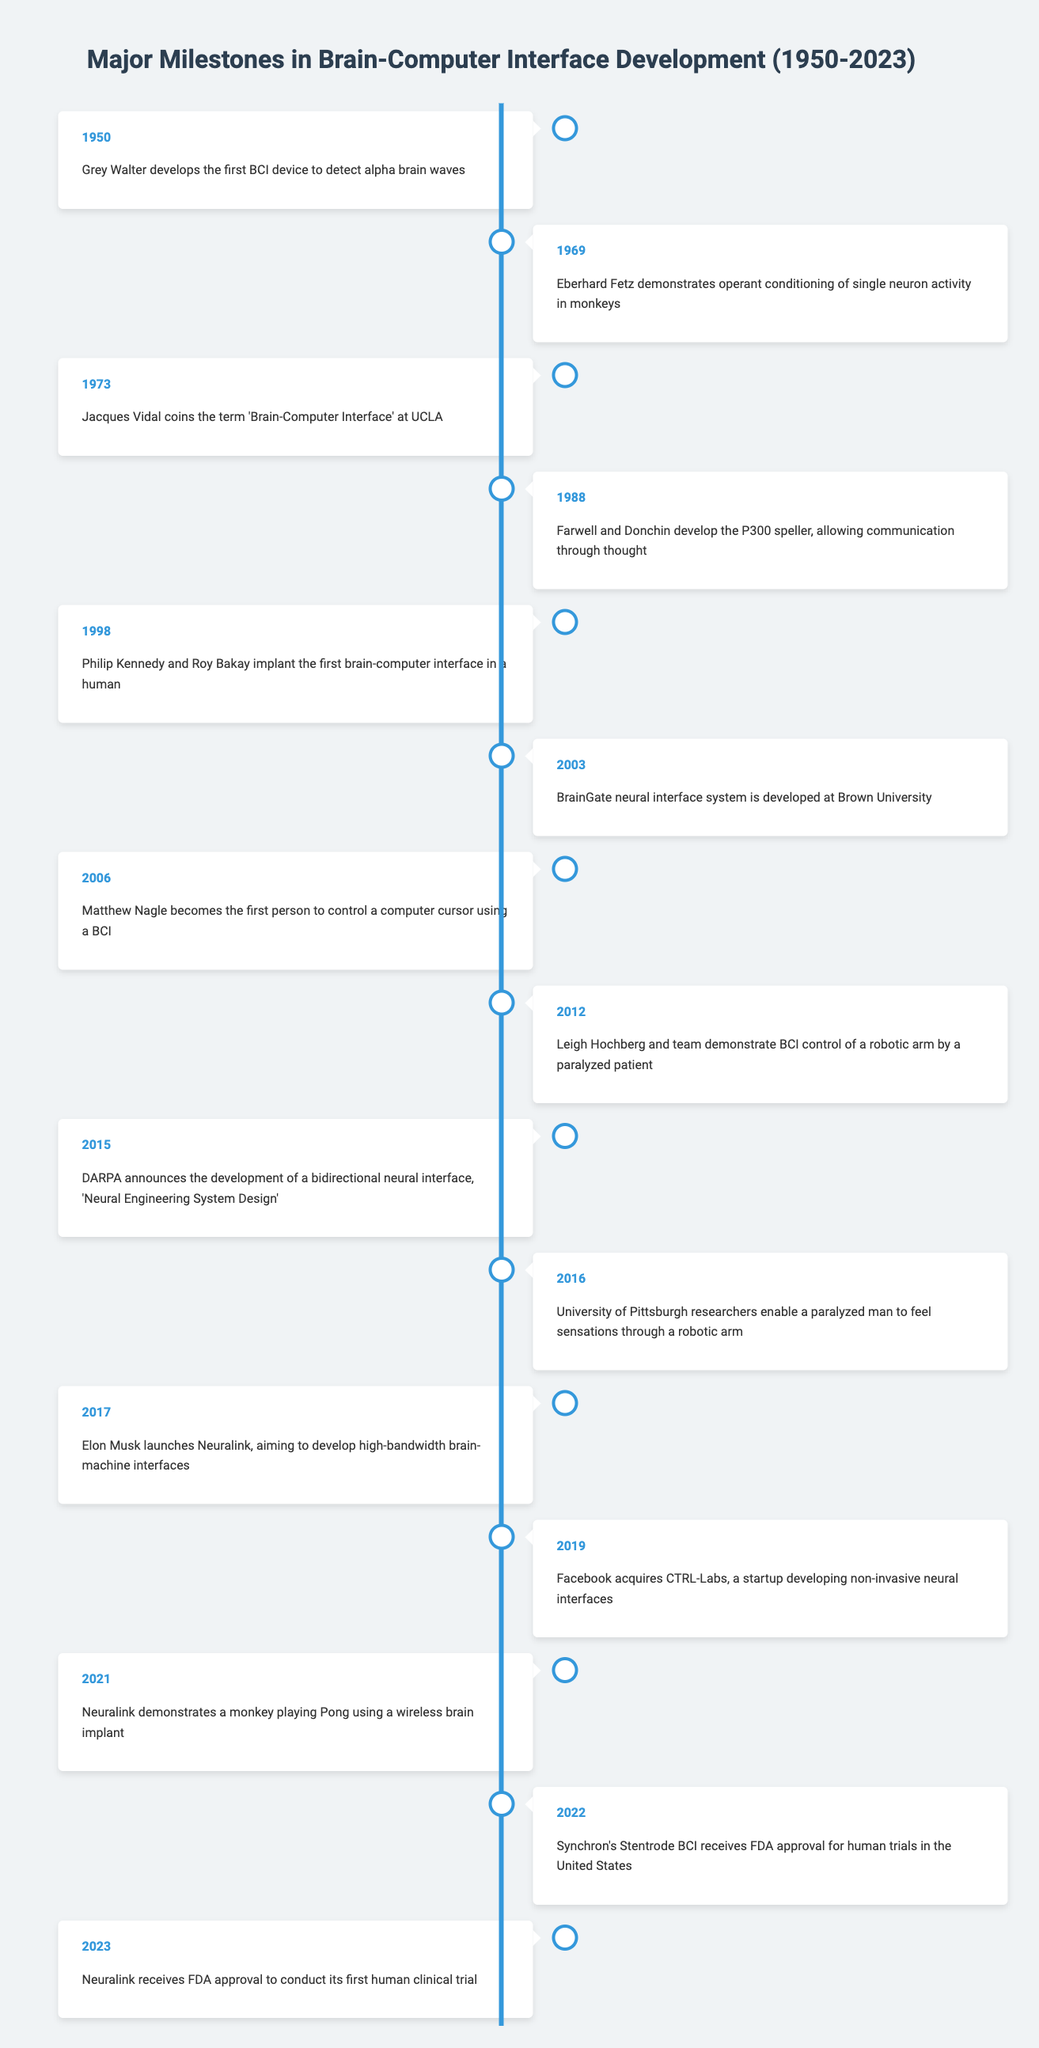What significant development occurred in 1973? The table indicates that in 1973, Jacques Vidal coined the term "Brain-Computer Interface" at UCLA, marking it as a significant conceptual milestone in the field.
Answer: Jacques Vidal coins the term 'Brain-Computer Interface' at UCLA Which year did Neuralink demonstrate a monkey playing Pong? The table states that Neuralink demonstrated a monkey playing Pong using a wireless brain implant in 2021. This can be directly retrieved from the respective row in the timeline.
Answer: 2021 Was the first human brain-computer interface implant conducted in 1998? Looking at the timeline, it shows that in 1998, Philip Kennedy and Roy Bakay implanted the first brain-computer interface in a human. Therefore, the statement is true as this event is clearly outlined in the table.
Answer: Yes How many years passed between the development of the P300 speller and the first brain-computer interface implant in a human? The P300 speller was developed in 1988, and the first human implant occurred in 1998. The difference is 1998 - 1988, which equals 10 years. This calculation can be derived by directly referring to the years of the corresponding events in the table.
Answer: 10 years In which year did a paralyzed patient control a robotic arm using a BCI? According to the table, Leigh Hochberg and team demonstrated BCI control of a robotic arm by a paralyzed patient in 2012. This information is clearly stated in the timeline, allowing for straightforward retrieval.
Answer: 2012 List the first and last events in the timeline. The first event is from 1950 when Grey Walter developed the first BCI device, and the last event is from 2023 when Neuralink received FDA approval for its first human clinical trial. This can be determined by looking at the years listed in the timeline, confirming the earliest and latest entries.
Answer: 1950 and 2023 How many significant events occurred in the 2010s? The table lists four significant events in the 2010s: 2012, 2015, 2016, and 2017. Counting these years provides the total number of notable developments in that decade.
Answer: 4 events Did any event occur in the 1960s related to BCI development? Yes, according to the timeline, Eberhard Fetz demonstrated operant conditioning of single neuron activity in monkeys in 1969, thus confirming that there was indeed an event in the 1960s directly related to BCI development.
Answer: Yes What is the chronological order of significant events from 1988 to 2016? According to the timeline, the events are as follows: 1988 - P300 speller, 1998 - first human implant, 2003 - BrainGate system, 2006 - first computer cursor control, 2012 - robotic arm control demonstration, 2015 - bidirectional neural interface development, 2016 - enabling sensations through a robotic arm. This sequential arrangement is derived from the years listed and their corresponding events in the table.
Answer: 1988, 1998, 2003, 2006, 2012, 2015, 2016 